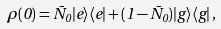<formula> <loc_0><loc_0><loc_500><loc_500>\rho ( 0 ) = \bar { N } _ { 0 } | e \rangle \langle e | + ( 1 - \bar { N } _ { 0 } ) | g \rangle \langle g | \, ,</formula> 